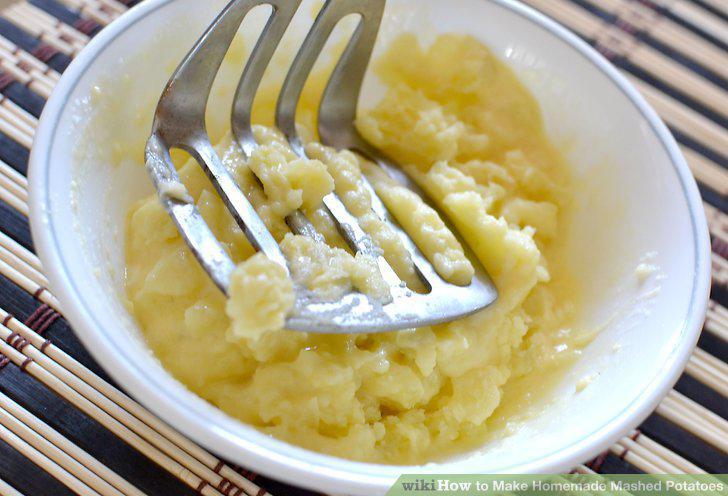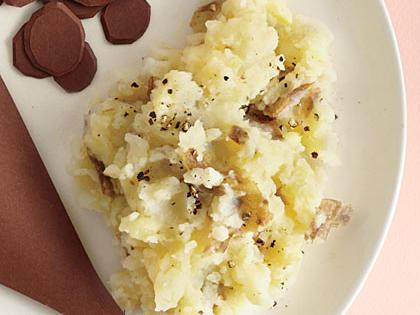The first image is the image on the left, the second image is the image on the right. Analyze the images presented: Is the assertion "The right image contains mashed potatoes in a green bowl." valid? Answer yes or no. No. 